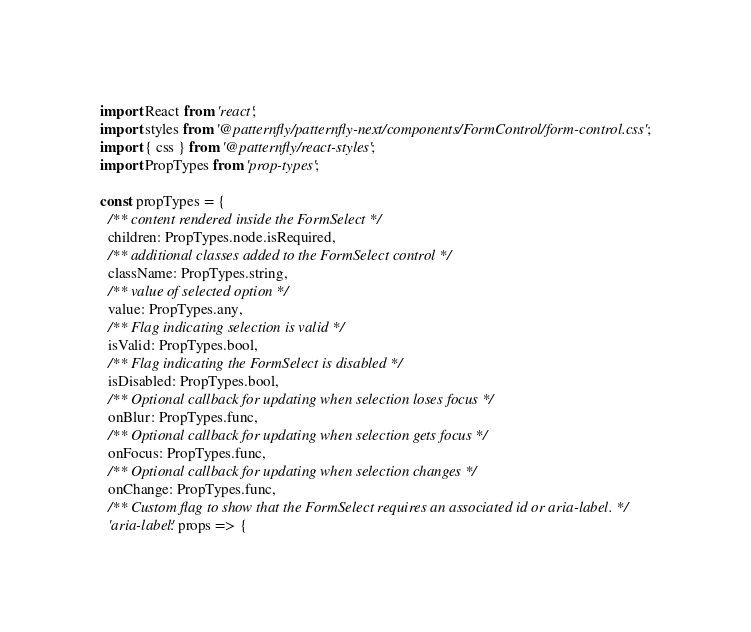<code> <loc_0><loc_0><loc_500><loc_500><_JavaScript_>import React from 'react';
import styles from '@patternfly/patternfly-next/components/FormControl/form-control.css';
import { css } from '@patternfly/react-styles';
import PropTypes from 'prop-types';

const propTypes = {
  /** content rendered inside the FormSelect */
  children: PropTypes.node.isRequired,
  /** additional classes added to the FormSelect control */
  className: PropTypes.string,
  /** value of selected option */
  value: PropTypes.any,
  /** Flag indicating selection is valid */
  isValid: PropTypes.bool,
  /** Flag indicating the FormSelect is disabled */
  isDisabled: PropTypes.bool,
  /** Optional callback for updating when selection loses focus */
  onBlur: PropTypes.func,
  /** Optional callback for updating when selection gets focus */
  onFocus: PropTypes.func,
  /** Optional callback for updating when selection changes */
  onChange: PropTypes.func,
  /** Custom flag to show that the FormSelect requires an associated id or aria-label. */
  'aria-label': props => {</code> 